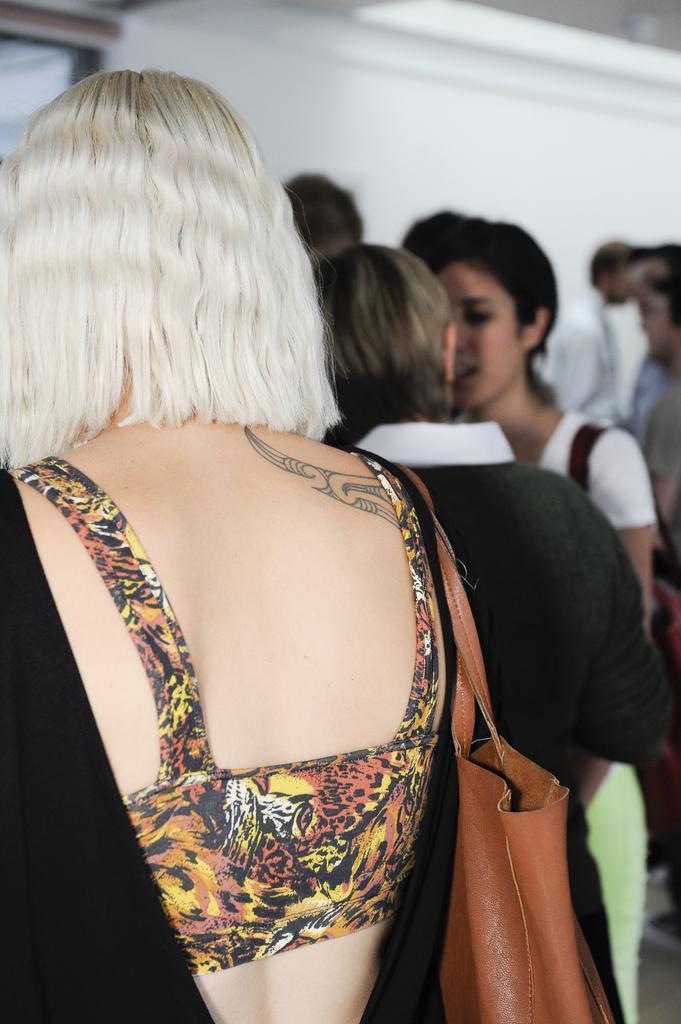In one or two sentences, can you explain what this image depicts? In this image I can see the group of people with different color dresses. I can see few people with the bag. I can see the white background. 